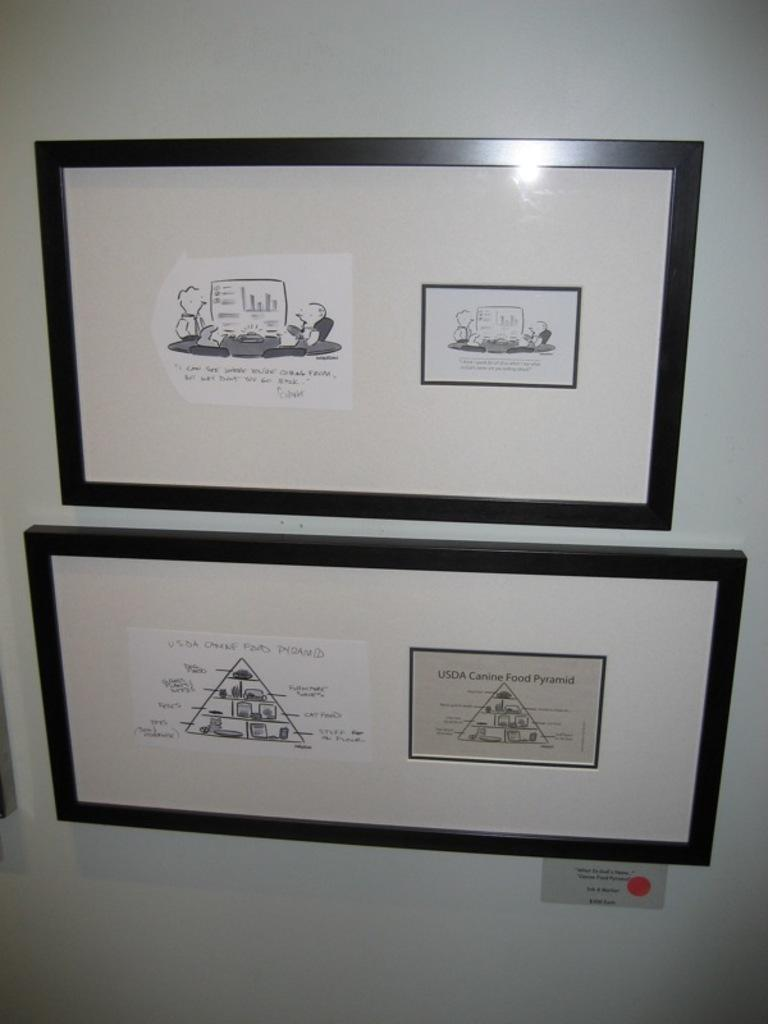What is present on the wall in the image? There are two frames on the wall in the image. What is written on the frames? There is writing on the frames. What do the frames depict? The frames depict persons. Where is the cave located in the image? There is no cave present in the image. What question is being asked by the bee in the image? There is no bee present in the image, and therefore no question being asked. 